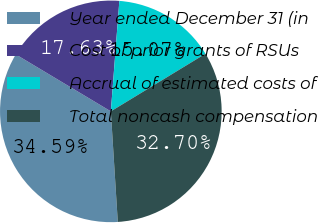Convert chart. <chart><loc_0><loc_0><loc_500><loc_500><pie_chart><fcel>Year ended December 31 (in<fcel>Cost of prior grants of RSUs<fcel>Accrual of estimated costs of<fcel>Total noncash compensation<nl><fcel>34.59%<fcel>17.63%<fcel>15.07%<fcel>32.7%<nl></chart> 